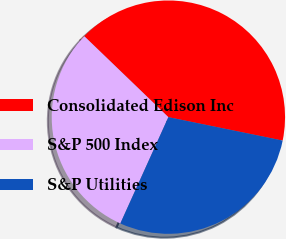Convert chart to OTSL. <chart><loc_0><loc_0><loc_500><loc_500><pie_chart><fcel>Consolidated Edison Inc<fcel>S&P 500 Index<fcel>S&P Utilities<nl><fcel>41.02%<fcel>30.44%<fcel>28.54%<nl></chart> 